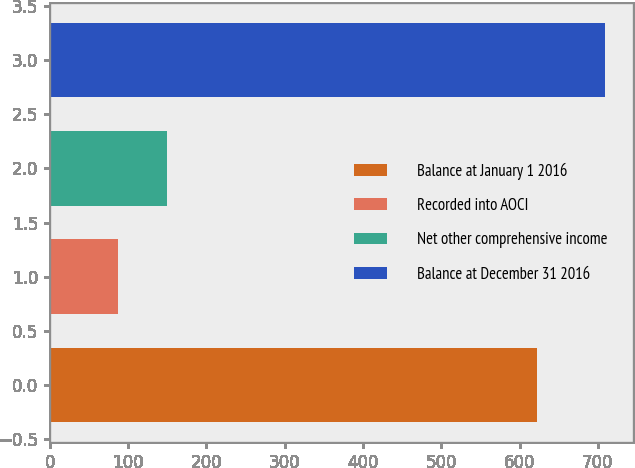Convert chart to OTSL. <chart><loc_0><loc_0><loc_500><loc_500><bar_chart><fcel>Balance at January 1 2016<fcel>Recorded into AOCI<fcel>Net other comprehensive income<fcel>Balance at December 31 2016<nl><fcel>622.3<fcel>87.1<fcel>149.33<fcel>709.4<nl></chart> 